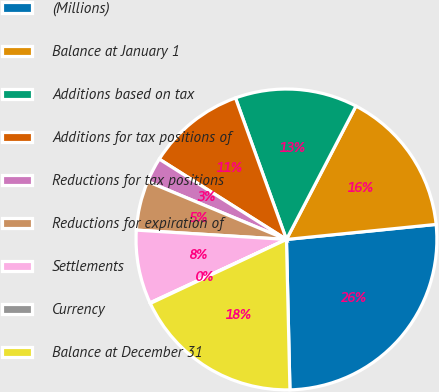Convert chart to OTSL. <chart><loc_0><loc_0><loc_500><loc_500><pie_chart><fcel>(Millions)<fcel>Balance at January 1<fcel>Additions based on tax<fcel>Additions for tax positions of<fcel>Reductions for tax positions<fcel>Reductions for expiration of<fcel>Settlements<fcel>Currency<fcel>Balance at December 31<nl><fcel>26.23%<fcel>15.76%<fcel>13.15%<fcel>10.53%<fcel>2.68%<fcel>5.3%<fcel>7.91%<fcel>0.07%<fcel>18.38%<nl></chart> 